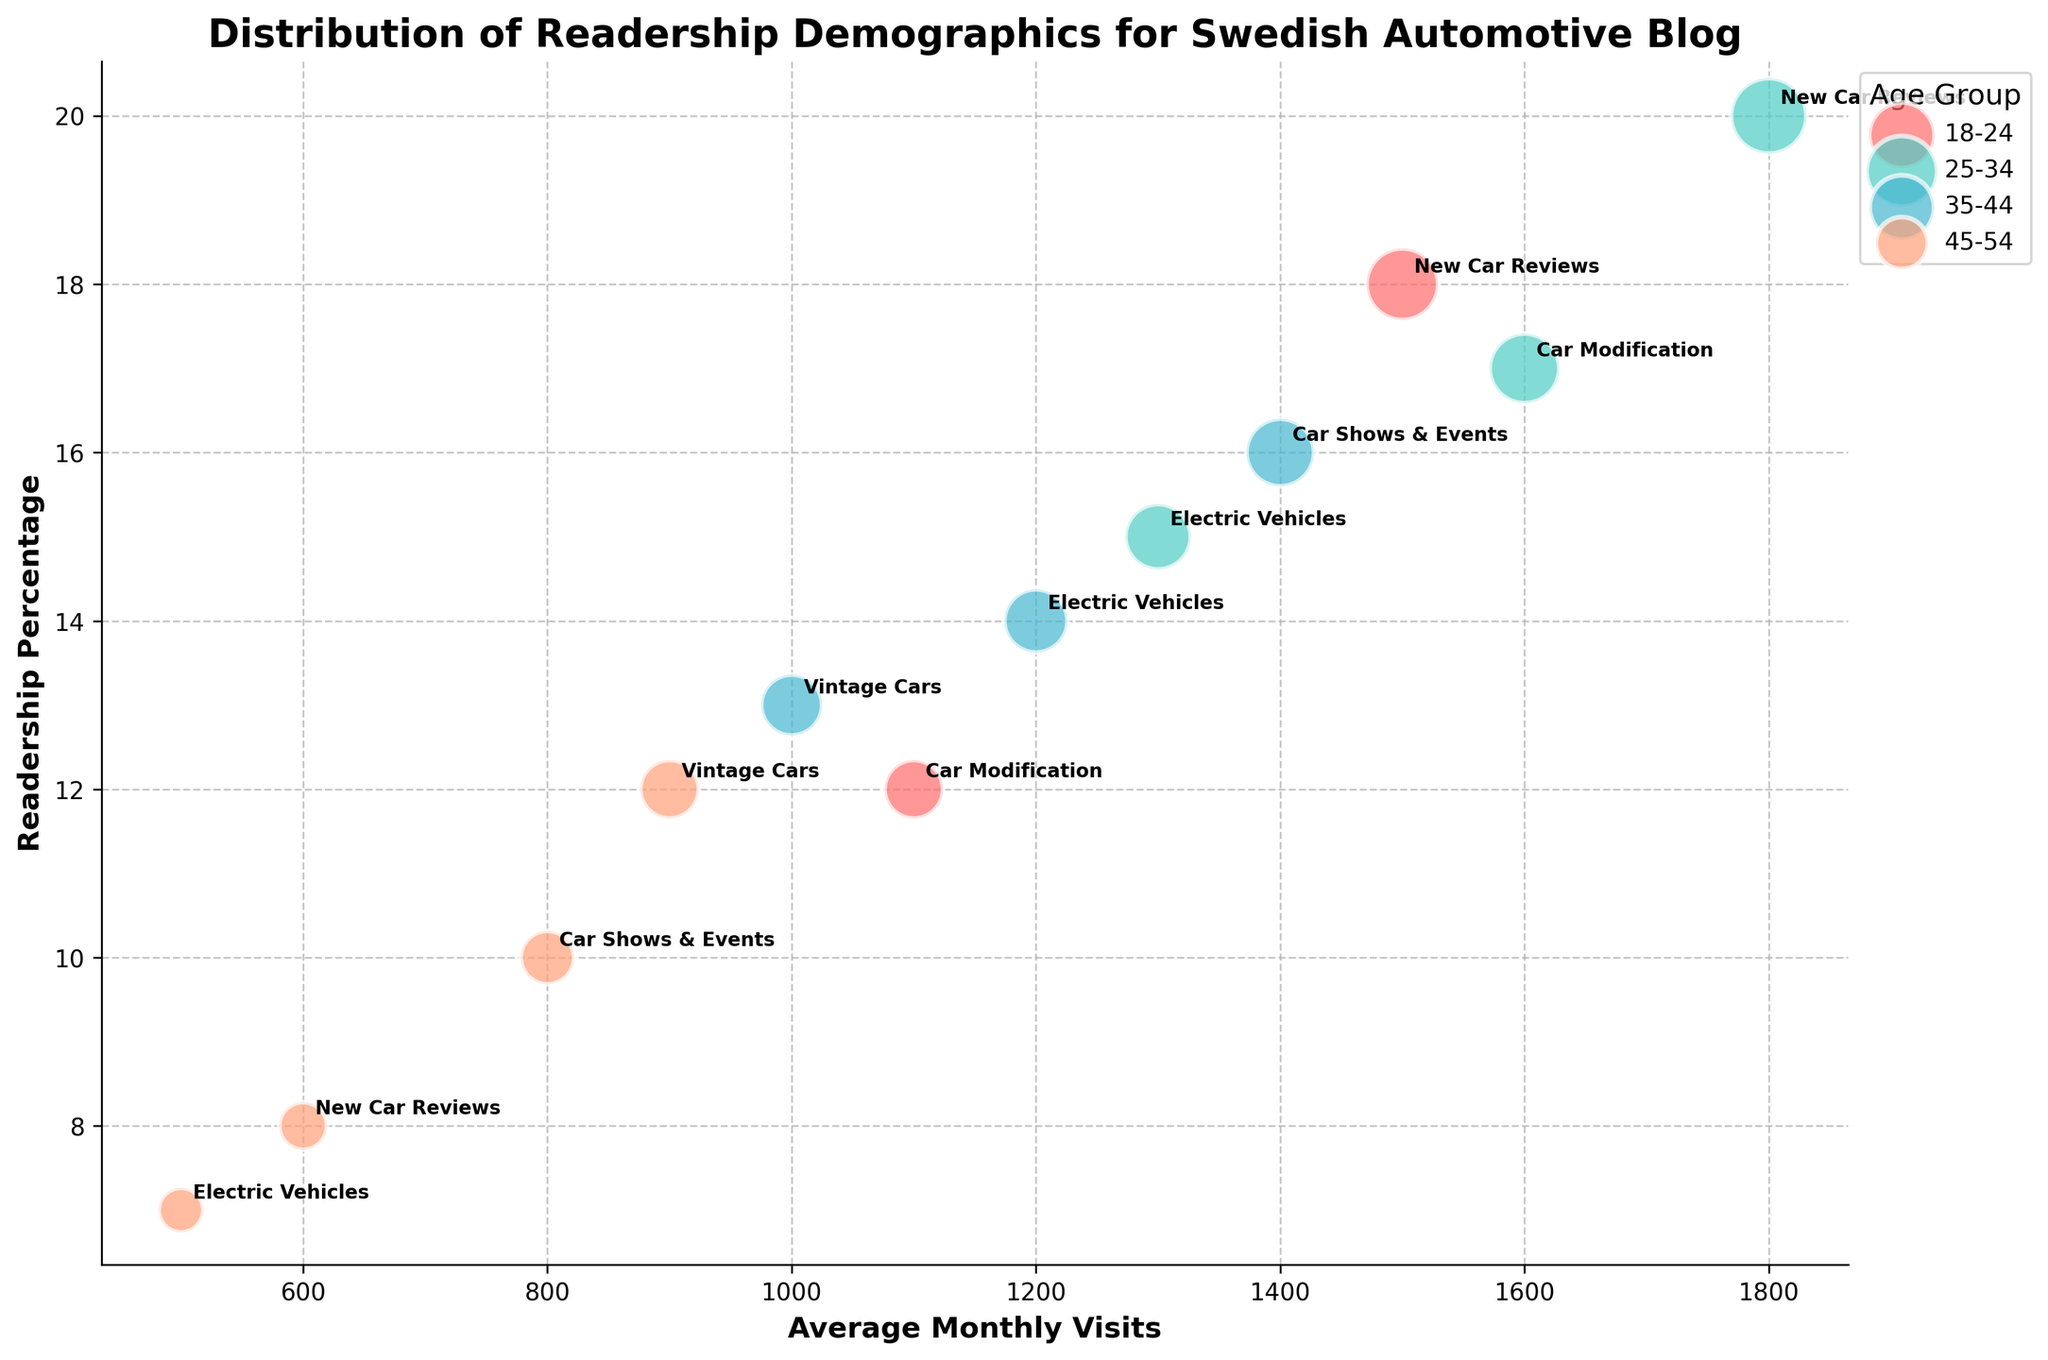How many age groups are represented in the chart? The legend lists all the unique age groups present in the data. By examining the legend on the right side of the chart, we can count the individual categories.
Answer: Four What is the title of the chart? The chart title is typically displayed at the top center.
Answer: Distribution of Readership Demographics for Swedish Automotive Blog Which age group has the highest readership percentage for 'Car Modification'? By looking at the bubbles labeled 'Car Modification' and the associated y-axis values, we can compare the readership percentages.
Answer: 25-34 What is the average monthly visits for 18-24 age group for 'New Car Reviews' and 'Car Modification'? Locate the bubbles for 'New Car Reviews' and 'Car Modification' under 18-24 age group and average their x-axis values: (1500 + 1100) / 2 = 1300.
Answer: 1300 Which interest has the smallest bubble in the 45-54 age group? Locate the clusters for the 45-54 age group and compare bubble sizes. The smallest bubble represents the interest with the smallest readership percentage.
Answer: Electric Vehicles How does the readership percentage for 'Vintage Cars' compare between 35-44 and 45-54 age groups? Find the bubbles labeled 'Vintage Cars' for both age groups and compare their positions on the y-axis.
Answer: Higher in 35-44 Which age group has the most diverse interests, based on the number of different interests? Count the number of unique categories within each age group by looking at the annotations (labels) of the bubbles clustered around each age group.
Answer: 25-34 What is the overall trend in readership percentage as age increases? Observe the general position of bubbles as age progresses from one group to the next. This involves interpreting the density and height of bubbles on the y-axis.
Answer: Decreases Is there any age group that shows a particular interest in Electric Vehicles? Look for the bubbles labeled 'Electric Vehicles' across all age groups and identify where they are more prominent or higher on the y-axis.
Answer: 25-34 